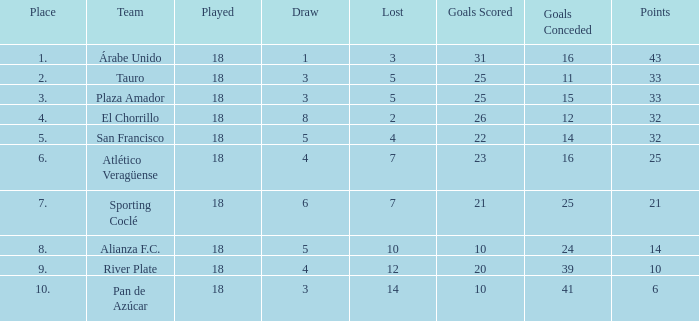How many goals were conceded by teams with 32 points, more than 2 losses and more than 22 goals scored? 0.0. 